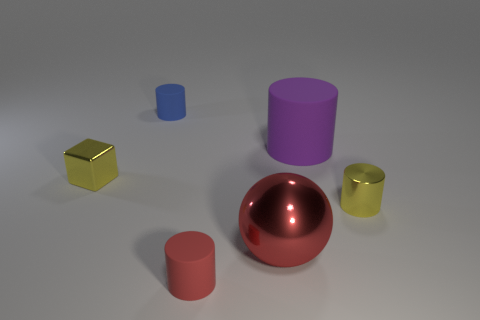Add 2 red balls. How many objects exist? 8 Subtract all brown cylinders. Subtract all red spheres. How many cylinders are left? 4 Subtract all cylinders. How many objects are left? 2 Subtract all large cyan spheres. Subtract all tiny yellow metallic blocks. How many objects are left? 5 Add 2 large matte things. How many large matte things are left? 3 Add 6 large blue shiny blocks. How many large blue shiny blocks exist? 6 Subtract 0 cyan cylinders. How many objects are left? 6 